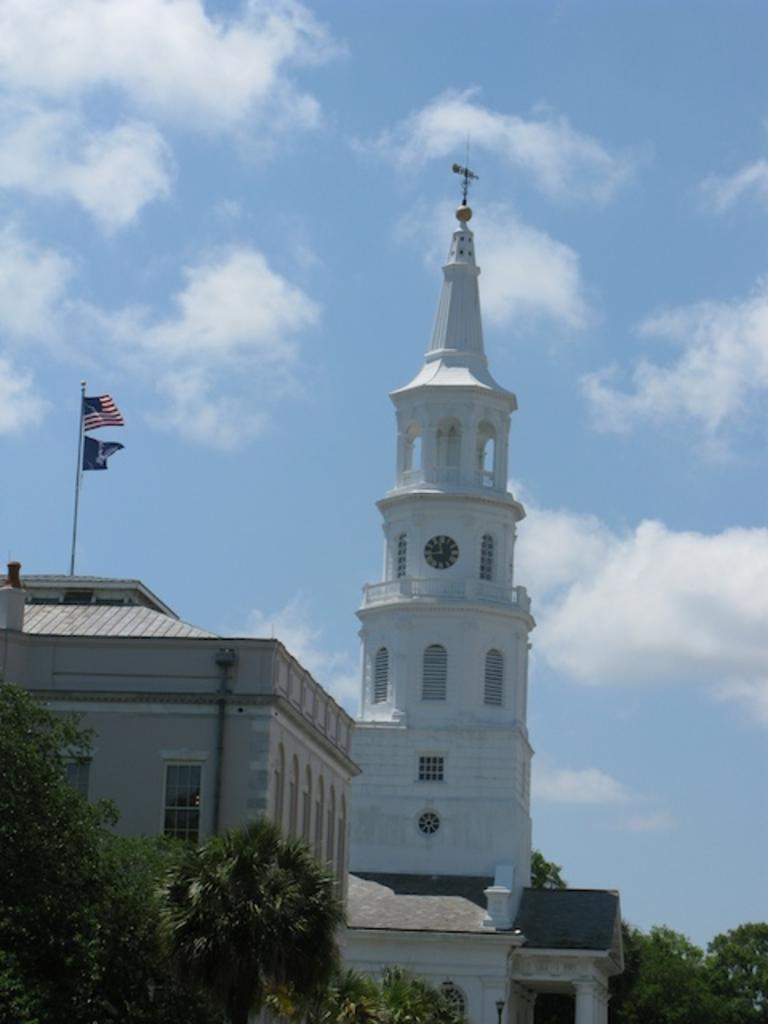In one or two sentences, can you explain what this image depicts? In the image there are buildings in the back with clock tower above it with flags on the left side building with trees in front of it and above its sky with clouds. 